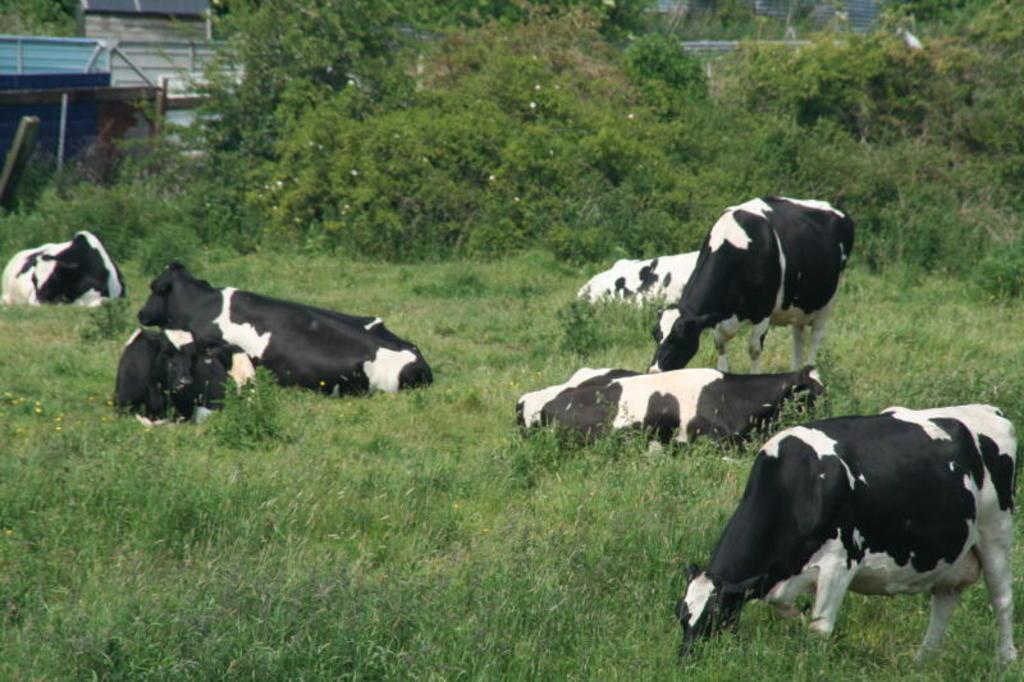What type of animals are in the image? There are black and white cows in the image. What are the cows doing in the image? The cows are sitting and eating grass. What can be seen in the background of the image? There are many trees visible in the background. Can you describe any structures in the background? There is a blue and white iron shed in the background. What type of fruit is the cow eating in the image? There is no fruit present in the image; the cows are eating grass. 